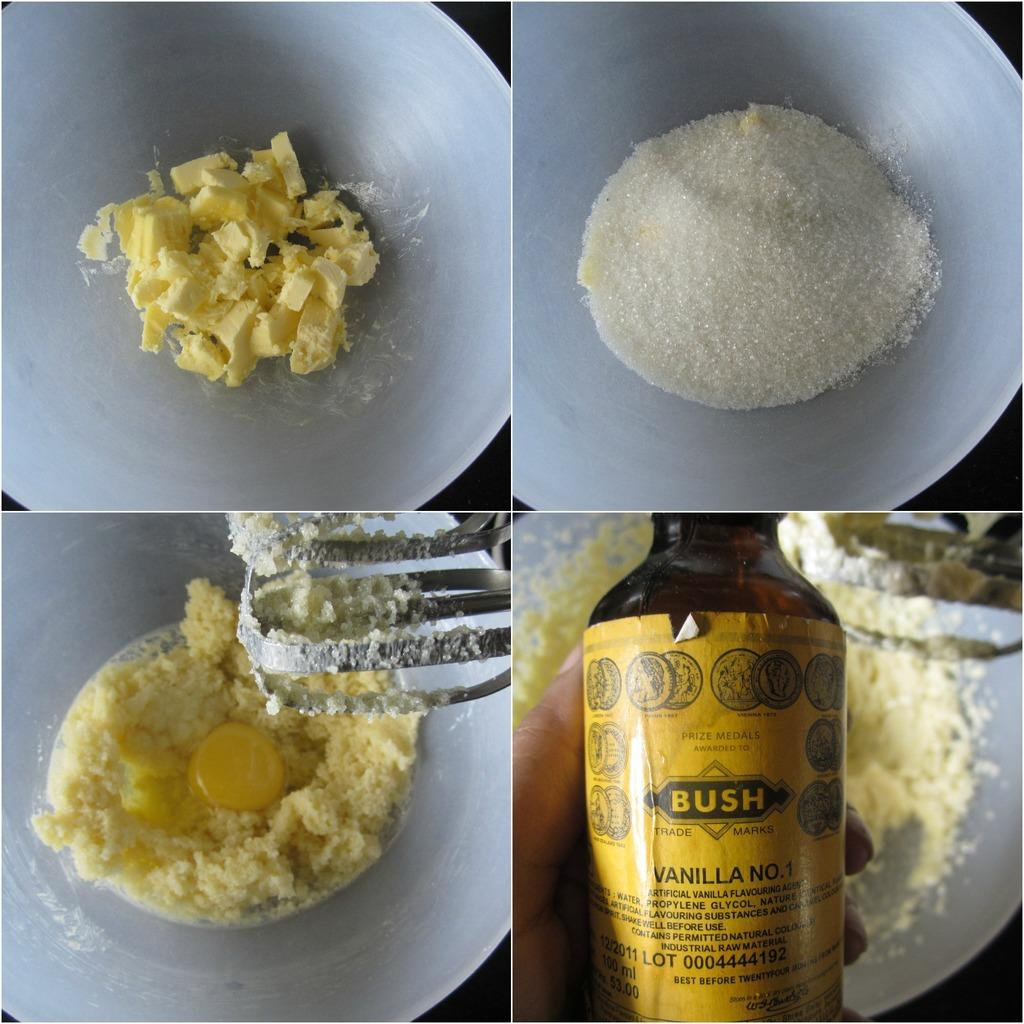<image>
Relay a brief, clear account of the picture shown. Collage of images from a recipe with the bottome right being a BUSH bottle. 